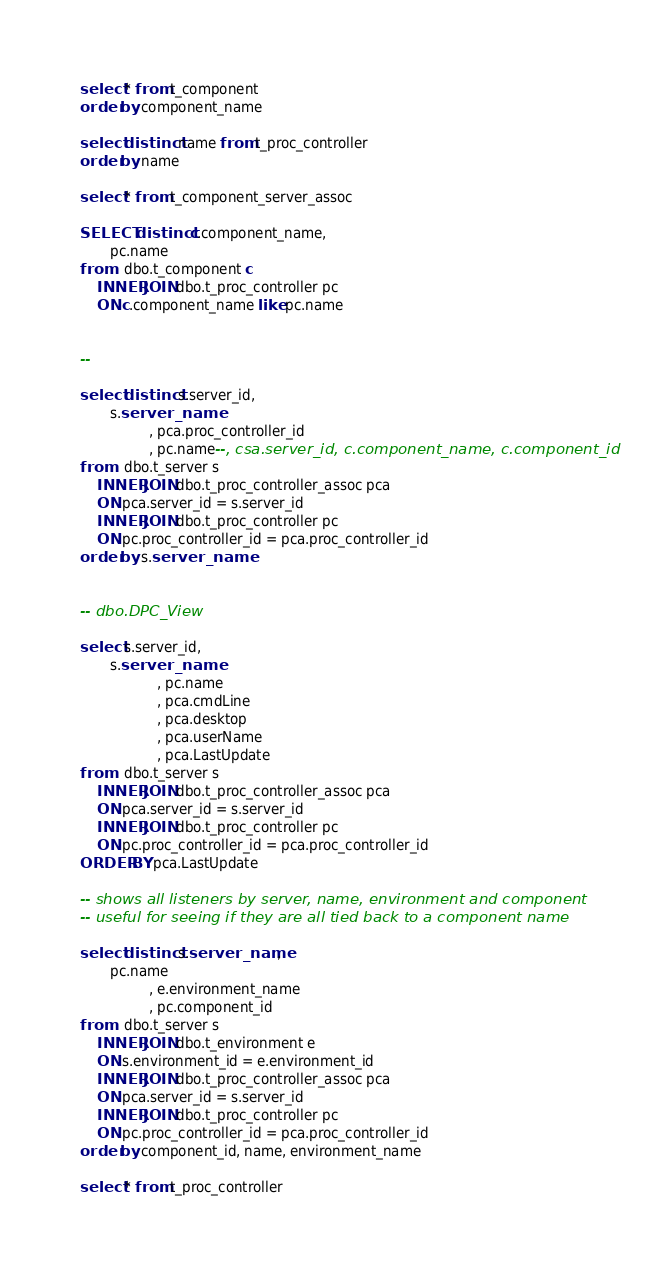Convert code to text. <code><loc_0><loc_0><loc_500><loc_500><_SQL_>
select * from t_component
order by component_name

select distinct name from t_proc_controller
order by name

select * from t_component_server_assoc

SELECT distinct c.component_name,
       pc.name
from   dbo.t_component c
    INNER JOIN dbo.t_proc_controller pc
    ON c.component_name like pc.name


-- 

select distinct s.server_id,
       s.server_name
                , pca.proc_controller_id
                , pc.name--, csa.server_id, c.component_name, c.component_id
from   dbo.t_server s
    INNER JOIN dbo.t_proc_controller_assoc pca
    ON pca.server_id = s.server_id
    INNER JOIN dbo.t_proc_controller pc
    ON pc.proc_controller_id = pca.proc_controller_id
order by s.server_name   


-- dbo.DPC_View

select s.server_id,
       s.server_name
                  , pc.name
                  , pca.cmdLine
                  , pca.desktop
                  , pca.userName
                  , pca.LastUpdate
from   dbo.t_server s
    INNER JOIN dbo.t_proc_controller_assoc pca
    ON pca.server_id = s.server_id
    INNER JOIN dbo.t_proc_controller pc
    ON pc.proc_controller_id = pca.proc_controller_id
ORDER BY pca.LastUpdate

-- shows all listeners by server, name, environment and component
-- useful for seeing if they are all tied back to a component name

select distinct s.server_name,
       pc.name
                , e.environment_name
                , pc.component_id
from   dbo.t_server s
    INNER JOIN dbo.t_environment e
    ON s.environment_id = e.environment_id
    INNER JOIN dbo.t_proc_controller_assoc pca
    ON pca.server_id = s.server_id
    INNER JOIN dbo.t_proc_controller pc
    ON pc.proc_controller_id = pca.proc_controller_id
order by component_id, name, environment_name

select * from t_proc_controller</code> 